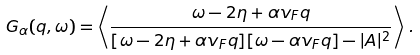<formula> <loc_0><loc_0><loc_500><loc_500>G _ { \alpha } ( q , \omega ) = \left \langle \frac { \omega - 2 \eta + \alpha v _ { F } q } { [ \omega - 2 \eta + \alpha v _ { F } q ] [ \omega - \alpha v _ { F } q ] - | A | ^ { 2 } } \right \rangle \, .</formula> 